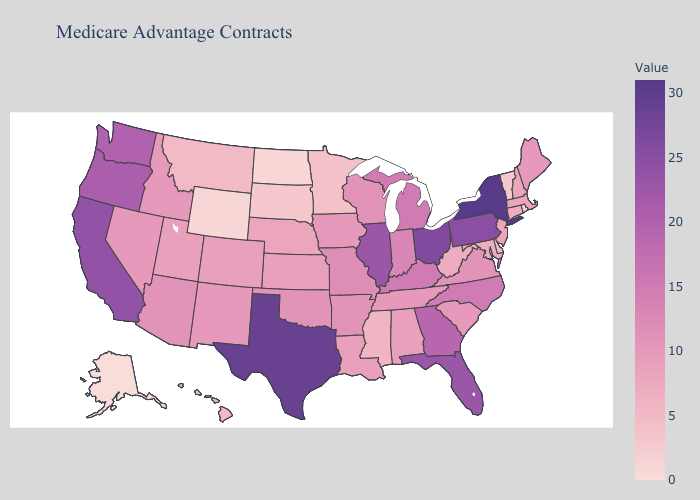Does Maryland have the highest value in the USA?
Give a very brief answer. No. Does Iowa have a higher value than New York?
Give a very brief answer. No. Which states have the lowest value in the South?
Keep it brief. Delaware. Does Ohio have the highest value in the MidWest?
Answer briefly. Yes. Does the map have missing data?
Concise answer only. No. Does Tennessee have the lowest value in the South?
Concise answer only. No. Which states have the lowest value in the MidWest?
Be succinct. North Dakota. Which states hav the highest value in the South?
Answer briefly. Texas. 